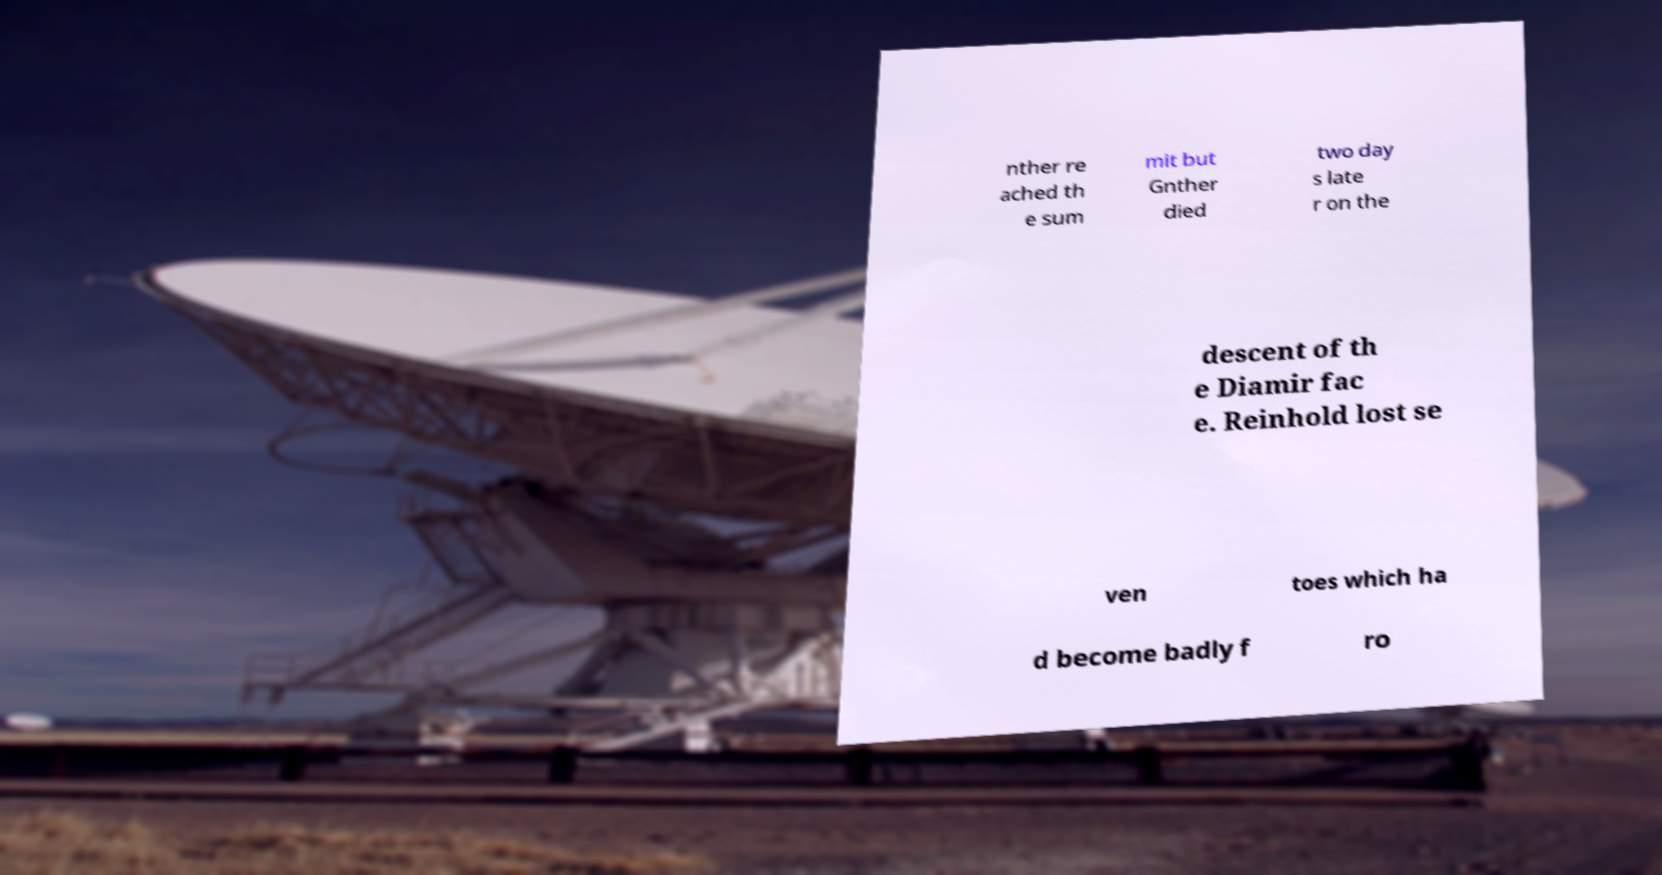Please read and relay the text visible in this image. What does it say? nther re ached th e sum mit but Gnther died two day s late r on the descent of th e Diamir fac e. Reinhold lost se ven toes which ha d become badly f ro 